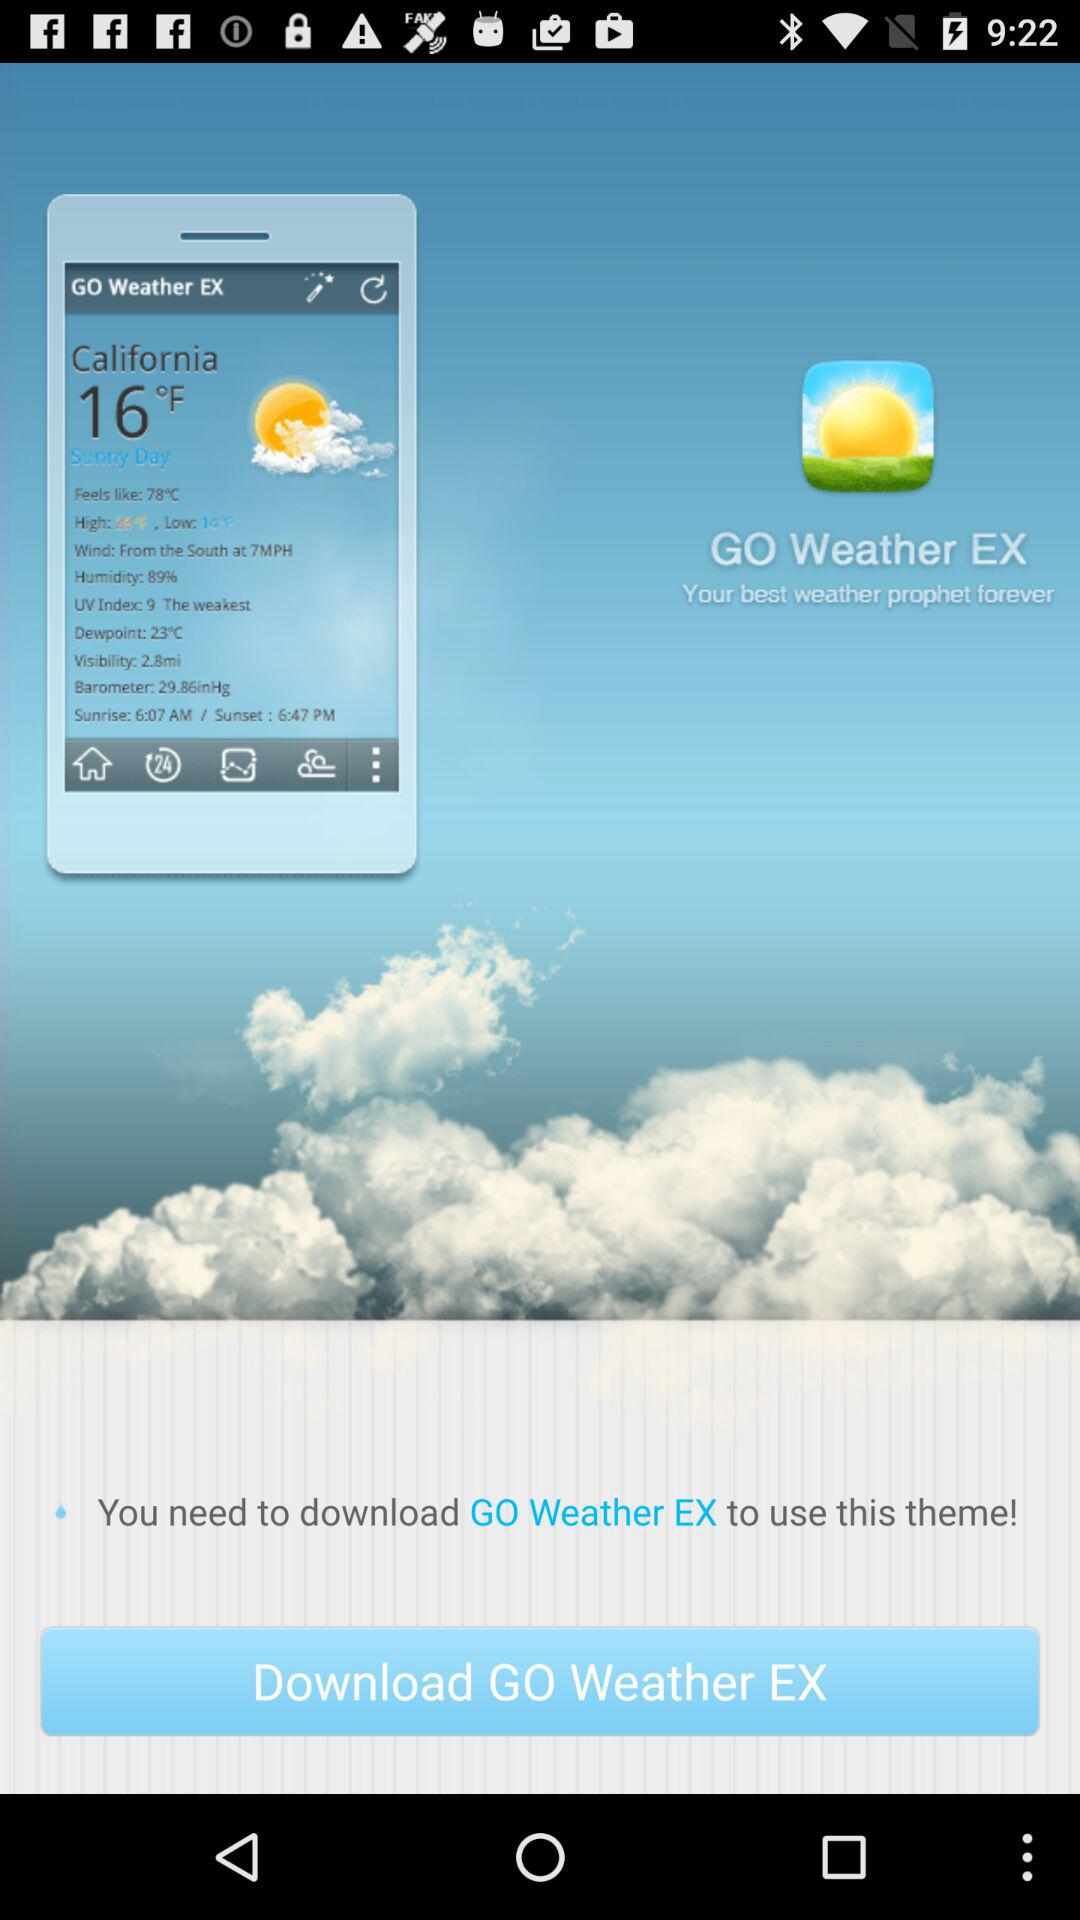What is the temperature in California? The temperature in California is 16°F. 